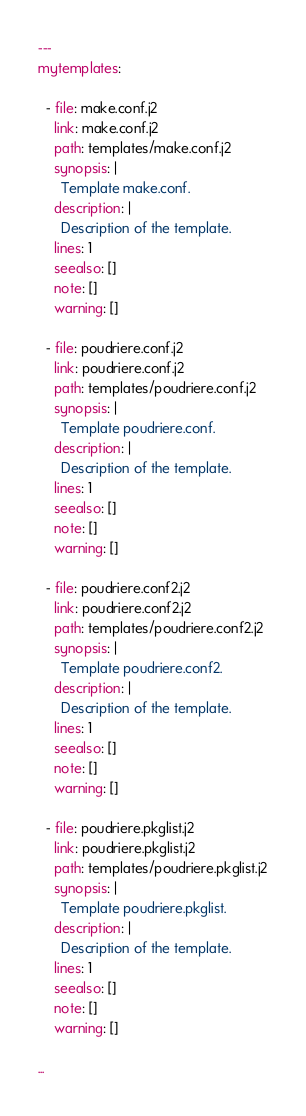Convert code to text. <code><loc_0><loc_0><loc_500><loc_500><_YAML_>---
mytemplates:

  - file: make.conf.j2
    link: make.conf.j2
    path: templates/make.conf.j2
    synopsis: |
      Template make.conf.
    description: |
      Description of the template.
    lines: 1
    seealso: []
    note: []
    warning: []

  - file: poudriere.conf.j2
    link: poudriere.conf.j2
    path: templates/poudriere.conf.j2
    synopsis: |
      Template poudriere.conf.
    description: |
      Description of the template.
    lines: 1
    seealso: []
    note: []
    warning: []

  - file: poudriere.conf2.j2
    link: poudriere.conf2.j2
    path: templates/poudriere.conf2.j2
    synopsis: |
      Template poudriere.conf2.
    description: |
      Description of the template.
    lines: 1
    seealso: []
    note: []
    warning: []

  - file: poudriere.pkglist.j2
    link: poudriere.pkglist.j2
    path: templates/poudriere.pkglist.j2
    synopsis: |
      Template poudriere.pkglist.
    description: |
      Description of the template.
    lines: 1
    seealso: []
    note: []
    warning: []

...
</code> 